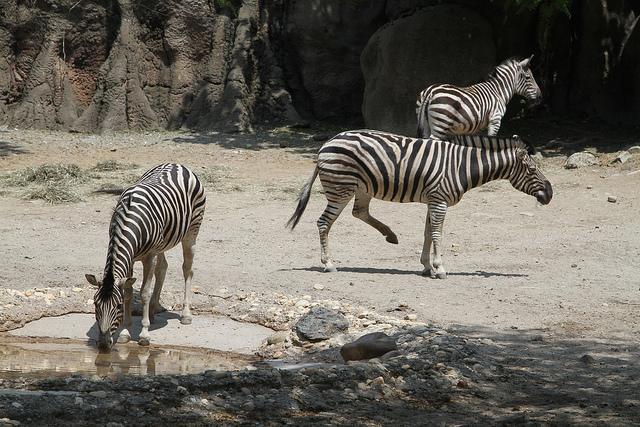How many zebras are drinking water?
Give a very brief answer. 1. How many zebra are fighting?
Give a very brief answer. 0. How many zebras are in the image?
Give a very brief answer. 3. How many zebras are in the photo?
Give a very brief answer. 3. 